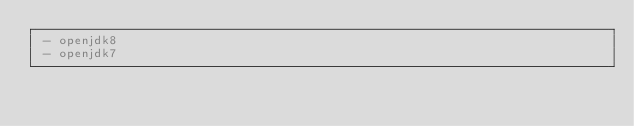Convert code to text. <code><loc_0><loc_0><loc_500><loc_500><_YAML_> - openjdk8
 - openjdk7

</code> 